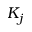Convert formula to latex. <formula><loc_0><loc_0><loc_500><loc_500>K _ { j }</formula> 